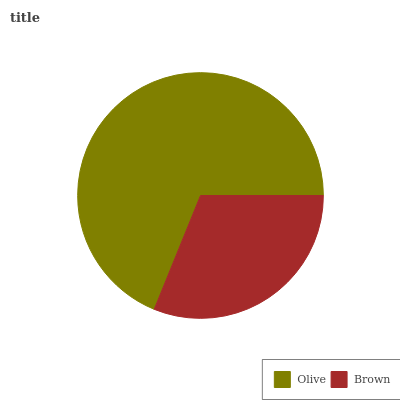Is Brown the minimum?
Answer yes or no. Yes. Is Olive the maximum?
Answer yes or no. Yes. Is Brown the maximum?
Answer yes or no. No. Is Olive greater than Brown?
Answer yes or no. Yes. Is Brown less than Olive?
Answer yes or no. Yes. Is Brown greater than Olive?
Answer yes or no. No. Is Olive less than Brown?
Answer yes or no. No. Is Olive the high median?
Answer yes or no. Yes. Is Brown the low median?
Answer yes or no. Yes. Is Brown the high median?
Answer yes or no. No. Is Olive the low median?
Answer yes or no. No. 